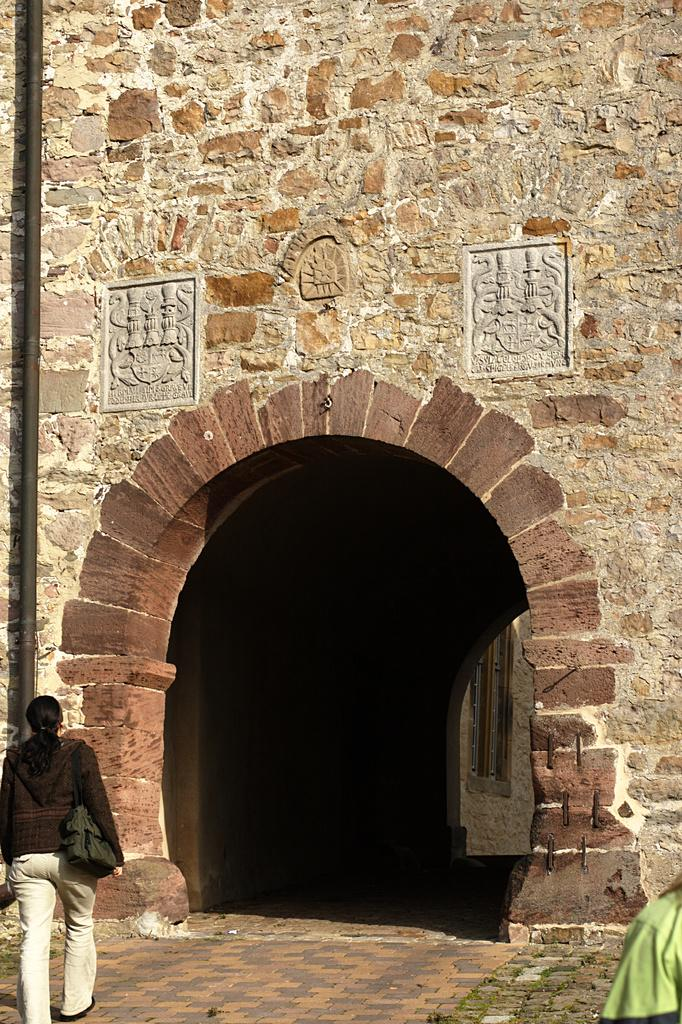What type of structure is featured in the image? There is a historical construction in the image. What architectural feature can be seen on the historical construction? The historical construction has a wall. Are there any other objects or figures in the image besides the historical construction? Yes, there are two sculptures in the image. What is the setting of the image? There is a path in the image, and a person is walking on it. How many frogs can be seen hopping along the path in the image? There are no frogs present in the image; it features a historical construction, two sculptures, and a person walking on a path. 